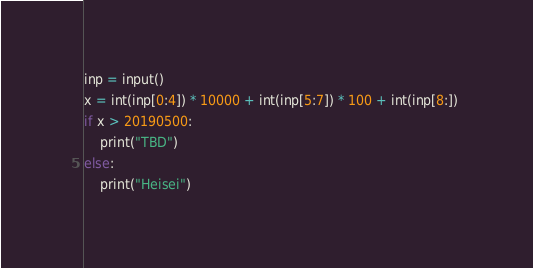Convert code to text. <code><loc_0><loc_0><loc_500><loc_500><_Python_>inp = input()
x = int(inp[0:4]) * 10000 + int(inp[5:7]) * 100 + int(inp[8:]) 
if x > 20190500:
    print("TBD")
else:
    print("Heisei")</code> 